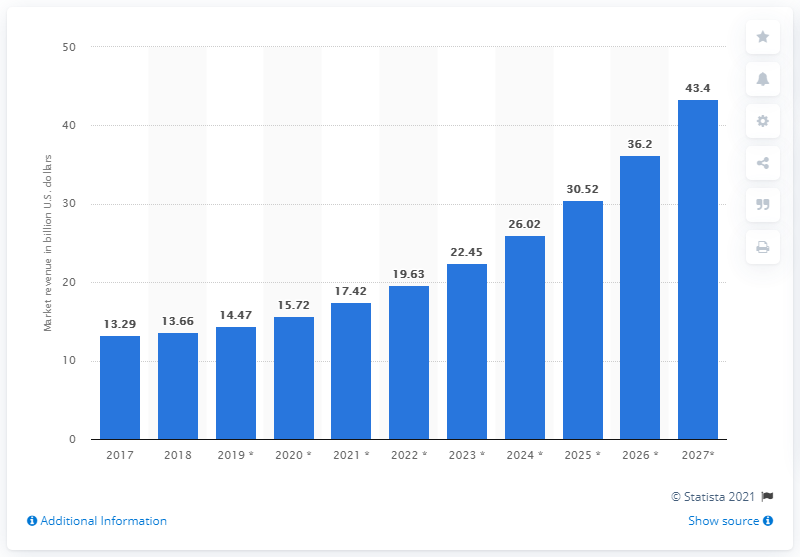Draw attention to some important aspects in this diagram. The projected size of the global smart kitchen market in 2019 is expected to be 14.47 billion dollars. The market size of the smart kitchen market is expected to reach 43.4 by 2027. 